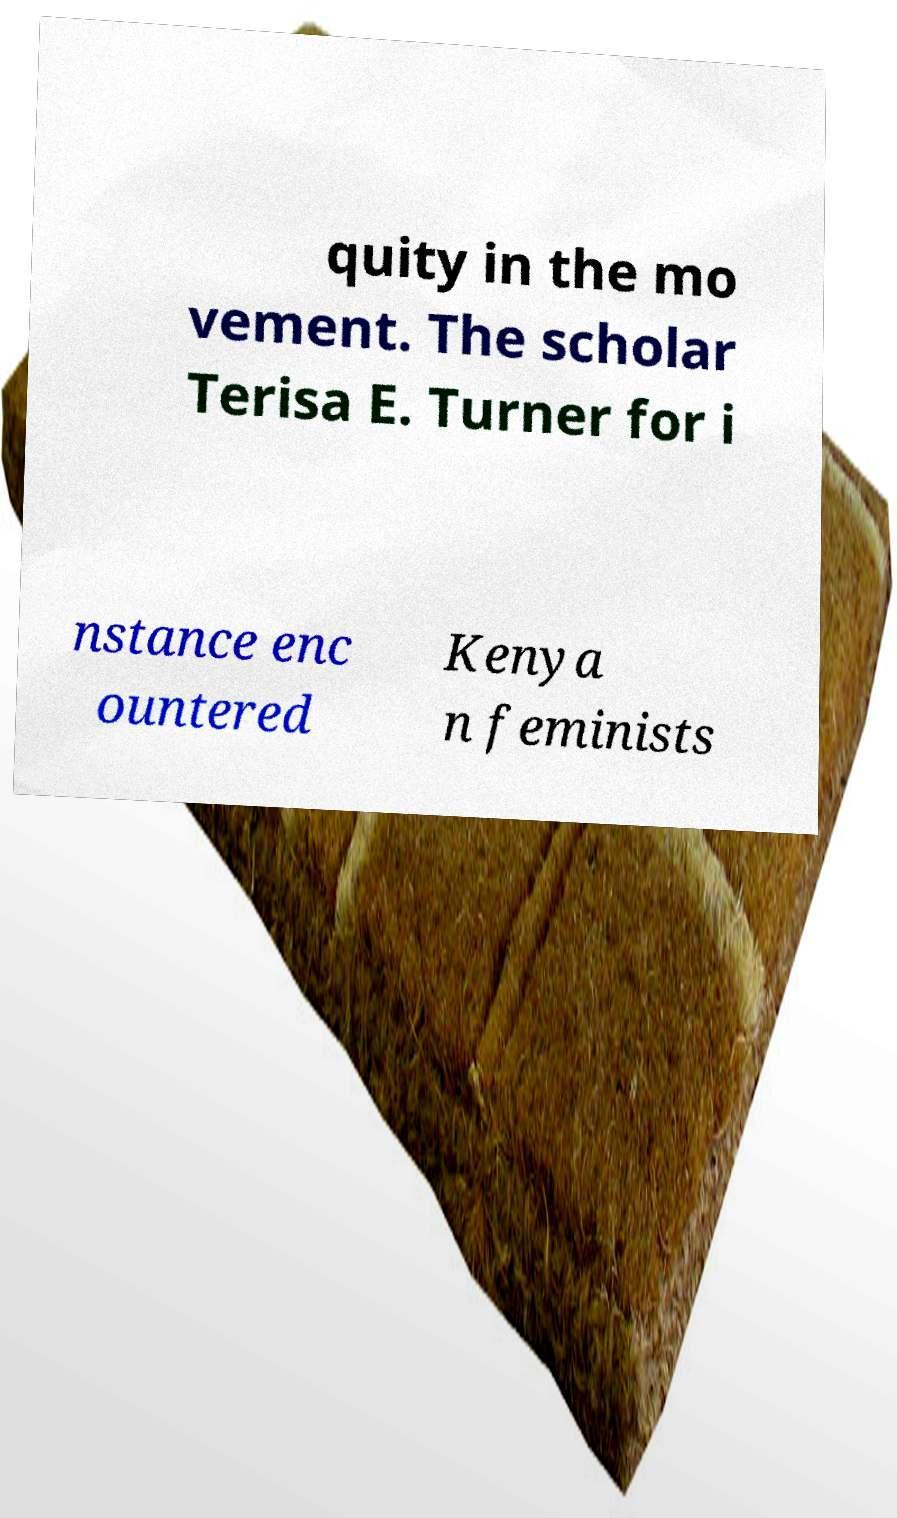I need the written content from this picture converted into text. Can you do that? quity in the mo vement. The scholar Terisa E. Turner for i nstance enc ountered Kenya n feminists 